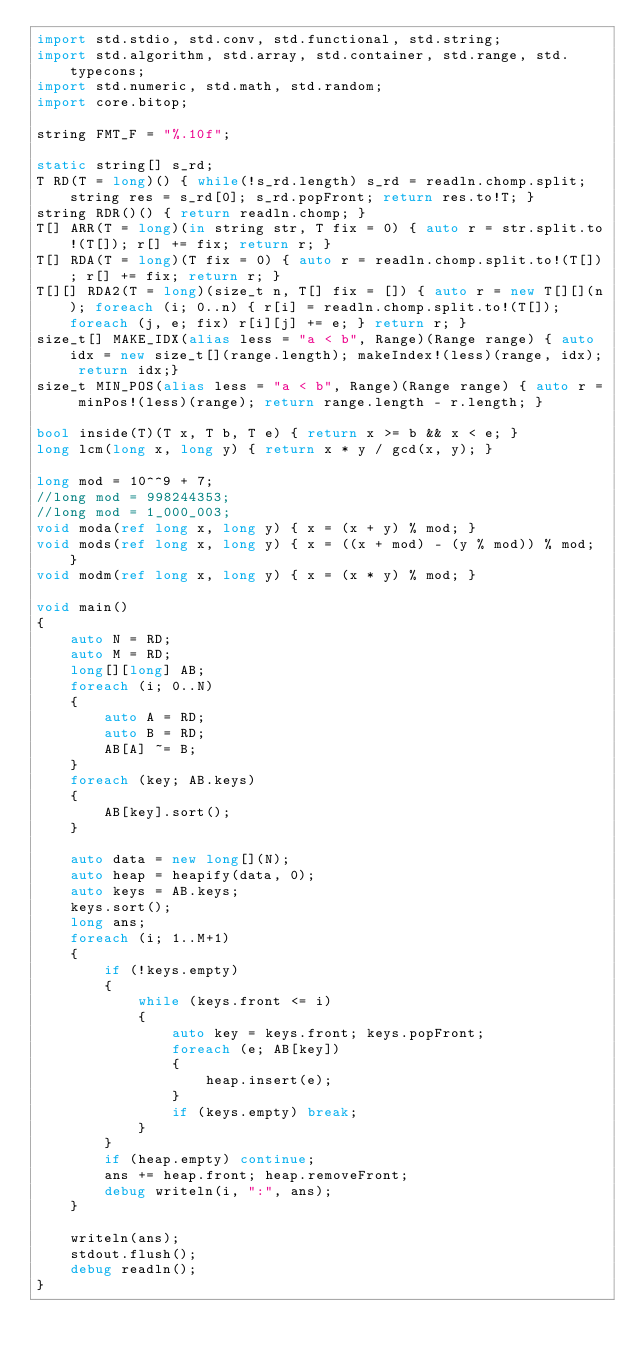Convert code to text. <code><loc_0><loc_0><loc_500><loc_500><_D_>import std.stdio, std.conv, std.functional, std.string;
import std.algorithm, std.array, std.container, std.range, std.typecons;
import std.numeric, std.math, std.random;
import core.bitop;

string FMT_F = "%.10f";

static string[] s_rd;
T RD(T = long)() { while(!s_rd.length) s_rd = readln.chomp.split; string res = s_rd[0]; s_rd.popFront; return res.to!T; }
string RDR()() { return readln.chomp; }
T[] ARR(T = long)(in string str, T fix = 0) { auto r = str.split.to!(T[]); r[] += fix; return r; }
T[] RDA(T = long)(T fix = 0) { auto r = readln.chomp.split.to!(T[]); r[] += fix; return r; }
T[][] RDA2(T = long)(size_t n, T[] fix = []) { auto r = new T[][](n); foreach (i; 0..n) { r[i] = readln.chomp.split.to!(T[]); foreach (j, e; fix) r[i][j] += e; } return r; }
size_t[] MAKE_IDX(alias less = "a < b", Range)(Range range) { auto idx = new size_t[](range.length); makeIndex!(less)(range, idx); return idx;}
size_t MIN_POS(alias less = "a < b", Range)(Range range) { auto r = minPos!(less)(range); return range.length - r.length; }

bool inside(T)(T x, T b, T e) { return x >= b && x < e; }
long lcm(long x, long y) { return x * y / gcd(x, y); }

long mod = 10^^9 + 7;
//long mod = 998244353;
//long mod = 1_000_003;
void moda(ref long x, long y) { x = (x + y) % mod; }
void mods(ref long x, long y) { x = ((x + mod) - (y % mod)) % mod; }
void modm(ref long x, long y) { x = (x * y) % mod; }

void main()
{
	auto N = RD;
	auto M = RD;
	long[][long] AB;
	foreach (i; 0..N)
	{
		auto A = RD;
		auto B = RD;
		AB[A] ~= B;
	}
	foreach (key; AB.keys)
	{
		AB[key].sort();
	}

	auto data = new long[](N);
	auto heap = heapify(data, 0);
	auto keys = AB.keys;
	keys.sort();
	long ans;
	foreach (i; 1..M+1)
	{
		if (!keys.empty)
		{
			while (keys.front <= i)
			{
				auto key = keys.front; keys.popFront;
				foreach (e; AB[key])
				{
					heap.insert(e);
				}
				if (keys.empty) break;
			}
		}
		if (heap.empty) continue;
		ans += heap.front; heap.removeFront;
		debug writeln(i, ":", ans);
	}

	writeln(ans);
	stdout.flush();
	debug readln();
}</code> 